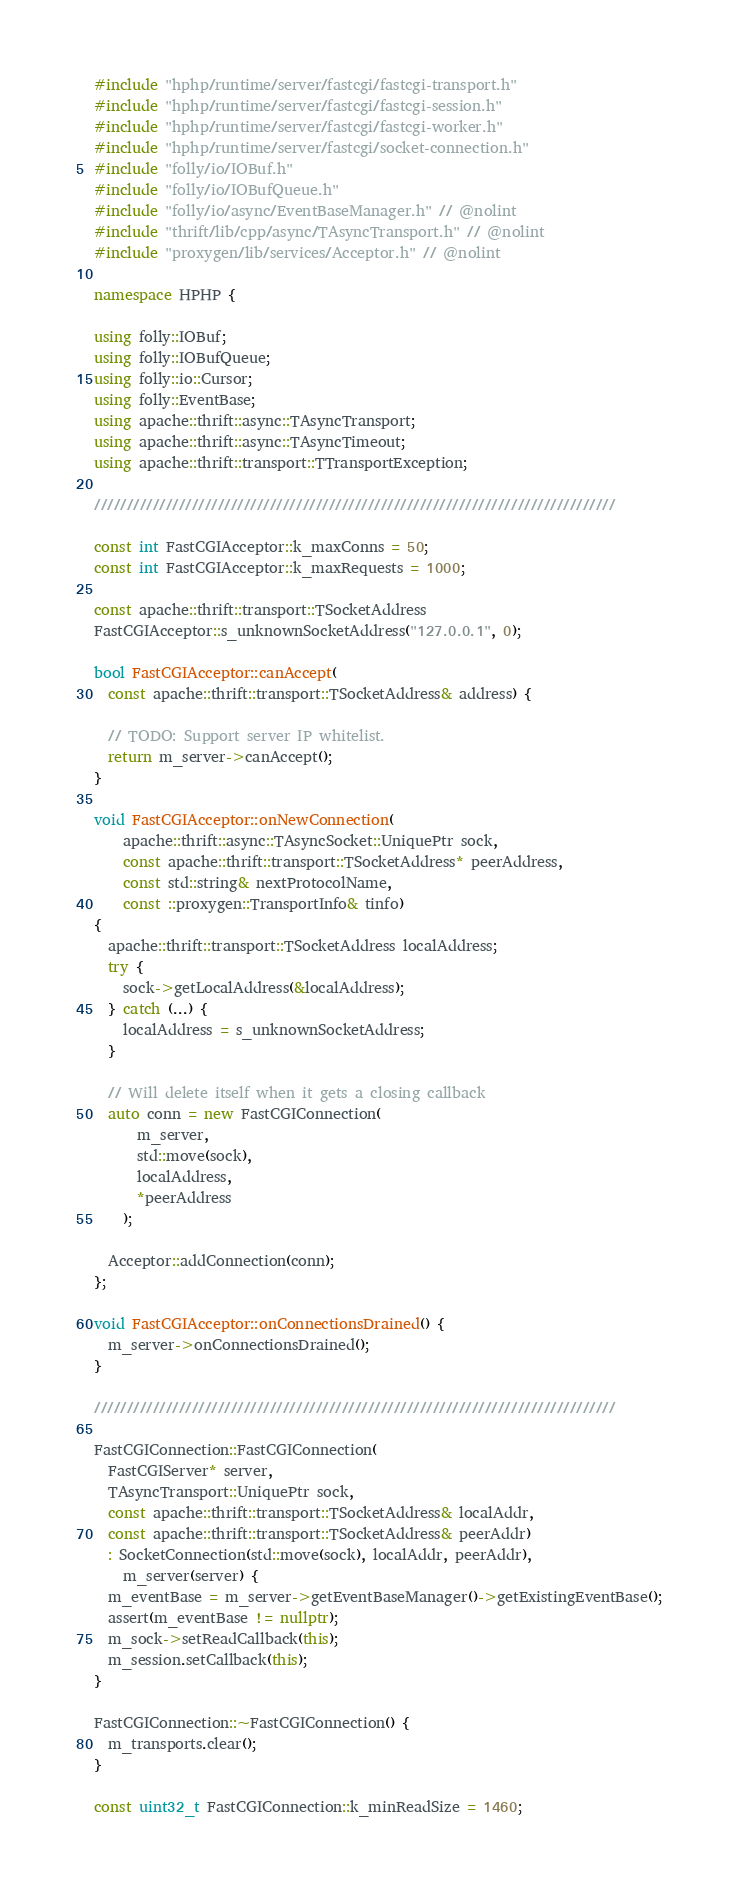<code> <loc_0><loc_0><loc_500><loc_500><_C++_>#include "hphp/runtime/server/fastcgi/fastcgi-transport.h"
#include "hphp/runtime/server/fastcgi/fastcgi-session.h"
#include "hphp/runtime/server/fastcgi/fastcgi-worker.h"
#include "hphp/runtime/server/fastcgi/socket-connection.h"
#include "folly/io/IOBuf.h"
#include "folly/io/IOBufQueue.h"
#include "folly/io/async/EventBaseManager.h" // @nolint
#include "thrift/lib/cpp/async/TAsyncTransport.h" // @nolint
#include "proxygen/lib/services/Acceptor.h" // @nolint

namespace HPHP {

using folly::IOBuf;
using folly::IOBufQueue;
using folly::io::Cursor;
using folly::EventBase;
using apache::thrift::async::TAsyncTransport;
using apache::thrift::async::TAsyncTimeout;
using apache::thrift::transport::TTransportException;

////////////////////////////////////////////////////////////////////////////////

const int FastCGIAcceptor::k_maxConns = 50;
const int FastCGIAcceptor::k_maxRequests = 1000;

const apache::thrift::transport::TSocketAddress
FastCGIAcceptor::s_unknownSocketAddress("127.0.0.1", 0);

bool FastCGIAcceptor::canAccept(
  const apache::thrift::transport::TSocketAddress& address) {

  // TODO: Support server IP whitelist.
  return m_server->canAccept();
}

void FastCGIAcceptor::onNewConnection(
    apache::thrift::async::TAsyncSocket::UniquePtr sock,
    const apache::thrift::transport::TSocketAddress* peerAddress,
    const std::string& nextProtocolName,
    const ::proxygen::TransportInfo& tinfo)
{
  apache::thrift::transport::TSocketAddress localAddress;
  try {
    sock->getLocalAddress(&localAddress);
  } catch (...) {
    localAddress = s_unknownSocketAddress;
  }

  // Will delete itself when it gets a closing callback
  auto conn = new FastCGIConnection(
      m_server,
      std::move(sock),
      localAddress,
      *peerAddress
    );

  Acceptor::addConnection(conn);
};

void FastCGIAcceptor::onConnectionsDrained() {
  m_server->onConnectionsDrained();
}

////////////////////////////////////////////////////////////////////////////////

FastCGIConnection::FastCGIConnection(
  FastCGIServer* server,
  TAsyncTransport::UniquePtr sock,
  const apache::thrift::transport::TSocketAddress& localAddr,
  const apache::thrift::transport::TSocketAddress& peerAddr)
  : SocketConnection(std::move(sock), localAddr, peerAddr),
    m_server(server) {
  m_eventBase = m_server->getEventBaseManager()->getExistingEventBase();
  assert(m_eventBase != nullptr);
  m_sock->setReadCallback(this);
  m_session.setCallback(this);
}

FastCGIConnection::~FastCGIConnection() {
  m_transports.clear();
}

const uint32_t FastCGIConnection::k_minReadSize = 1460;</code> 